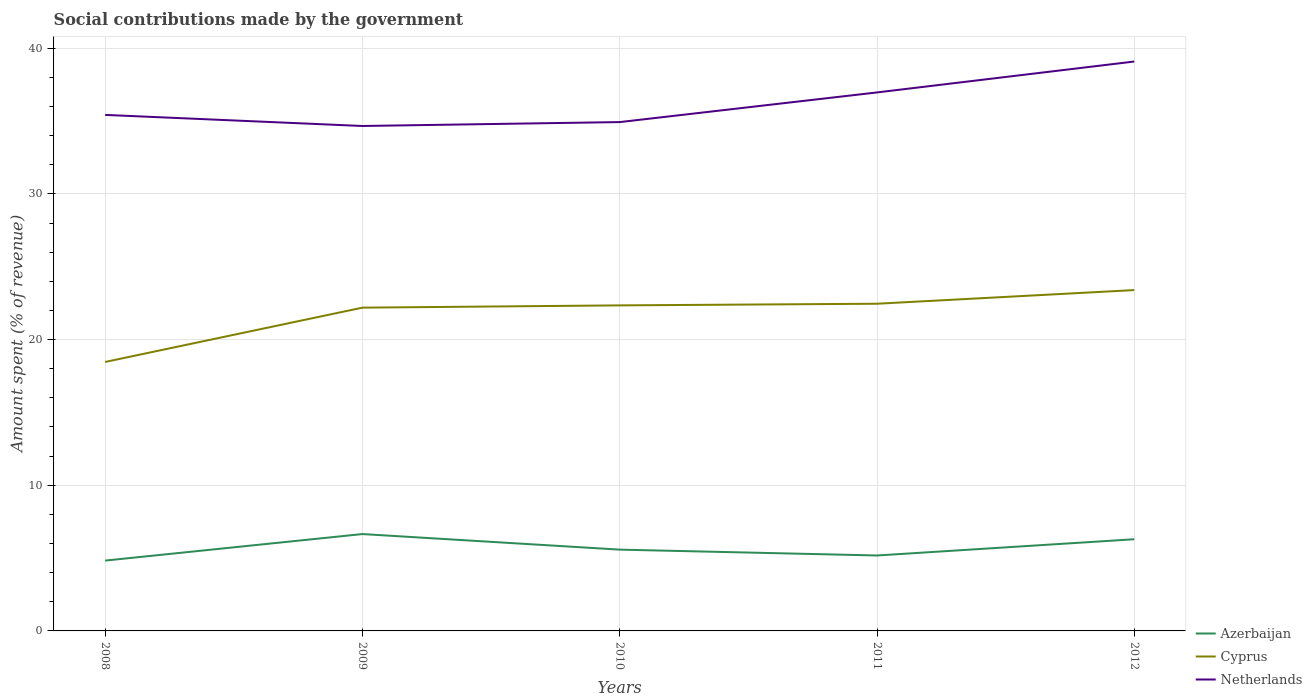How many different coloured lines are there?
Offer a very short reply. 3. Does the line corresponding to Cyprus intersect with the line corresponding to Netherlands?
Provide a succinct answer. No. Is the number of lines equal to the number of legend labels?
Give a very brief answer. Yes. Across all years, what is the maximum amount spent (in %) on social contributions in Azerbaijan?
Offer a terse response. 4.83. What is the total amount spent (in %) on social contributions in Cyprus in the graph?
Make the answer very short. -0.94. What is the difference between the highest and the second highest amount spent (in %) on social contributions in Cyprus?
Give a very brief answer. 4.93. What is the difference between two consecutive major ticks on the Y-axis?
Provide a short and direct response. 10. Are the values on the major ticks of Y-axis written in scientific E-notation?
Provide a short and direct response. No. Does the graph contain grids?
Make the answer very short. Yes. Where does the legend appear in the graph?
Ensure brevity in your answer.  Bottom right. How are the legend labels stacked?
Give a very brief answer. Vertical. What is the title of the graph?
Keep it short and to the point. Social contributions made by the government. What is the label or title of the X-axis?
Your answer should be compact. Years. What is the label or title of the Y-axis?
Provide a short and direct response. Amount spent (% of revenue). What is the Amount spent (% of revenue) of Azerbaijan in 2008?
Give a very brief answer. 4.83. What is the Amount spent (% of revenue) in Cyprus in 2008?
Your answer should be very brief. 18.46. What is the Amount spent (% of revenue) of Netherlands in 2008?
Provide a short and direct response. 35.42. What is the Amount spent (% of revenue) of Azerbaijan in 2009?
Provide a succinct answer. 6.65. What is the Amount spent (% of revenue) in Cyprus in 2009?
Your answer should be compact. 22.19. What is the Amount spent (% of revenue) in Netherlands in 2009?
Your answer should be very brief. 34.66. What is the Amount spent (% of revenue) of Azerbaijan in 2010?
Make the answer very short. 5.58. What is the Amount spent (% of revenue) in Cyprus in 2010?
Keep it short and to the point. 22.35. What is the Amount spent (% of revenue) of Netherlands in 2010?
Give a very brief answer. 34.93. What is the Amount spent (% of revenue) of Azerbaijan in 2011?
Your answer should be very brief. 5.18. What is the Amount spent (% of revenue) in Cyprus in 2011?
Keep it short and to the point. 22.46. What is the Amount spent (% of revenue) in Netherlands in 2011?
Provide a succinct answer. 36.96. What is the Amount spent (% of revenue) of Azerbaijan in 2012?
Your response must be concise. 6.29. What is the Amount spent (% of revenue) in Cyprus in 2012?
Give a very brief answer. 23.4. What is the Amount spent (% of revenue) in Netherlands in 2012?
Offer a terse response. 39.08. Across all years, what is the maximum Amount spent (% of revenue) of Azerbaijan?
Provide a succinct answer. 6.65. Across all years, what is the maximum Amount spent (% of revenue) in Cyprus?
Give a very brief answer. 23.4. Across all years, what is the maximum Amount spent (% of revenue) of Netherlands?
Provide a succinct answer. 39.08. Across all years, what is the minimum Amount spent (% of revenue) of Azerbaijan?
Your response must be concise. 4.83. Across all years, what is the minimum Amount spent (% of revenue) in Cyprus?
Offer a terse response. 18.46. Across all years, what is the minimum Amount spent (% of revenue) of Netherlands?
Ensure brevity in your answer.  34.66. What is the total Amount spent (% of revenue) in Azerbaijan in the graph?
Give a very brief answer. 28.53. What is the total Amount spent (% of revenue) in Cyprus in the graph?
Offer a terse response. 108.85. What is the total Amount spent (% of revenue) in Netherlands in the graph?
Offer a very short reply. 181.05. What is the difference between the Amount spent (% of revenue) of Azerbaijan in 2008 and that in 2009?
Your answer should be very brief. -1.82. What is the difference between the Amount spent (% of revenue) of Cyprus in 2008 and that in 2009?
Your response must be concise. -3.73. What is the difference between the Amount spent (% of revenue) in Netherlands in 2008 and that in 2009?
Your answer should be compact. 0.76. What is the difference between the Amount spent (% of revenue) in Azerbaijan in 2008 and that in 2010?
Your answer should be very brief. -0.75. What is the difference between the Amount spent (% of revenue) in Cyprus in 2008 and that in 2010?
Ensure brevity in your answer.  -3.88. What is the difference between the Amount spent (% of revenue) of Netherlands in 2008 and that in 2010?
Provide a short and direct response. 0.49. What is the difference between the Amount spent (% of revenue) in Azerbaijan in 2008 and that in 2011?
Keep it short and to the point. -0.35. What is the difference between the Amount spent (% of revenue) in Cyprus in 2008 and that in 2011?
Make the answer very short. -4. What is the difference between the Amount spent (% of revenue) in Netherlands in 2008 and that in 2011?
Give a very brief answer. -1.54. What is the difference between the Amount spent (% of revenue) of Azerbaijan in 2008 and that in 2012?
Ensure brevity in your answer.  -1.46. What is the difference between the Amount spent (% of revenue) of Cyprus in 2008 and that in 2012?
Provide a short and direct response. -4.93. What is the difference between the Amount spent (% of revenue) of Netherlands in 2008 and that in 2012?
Ensure brevity in your answer.  -3.66. What is the difference between the Amount spent (% of revenue) of Azerbaijan in 2009 and that in 2010?
Make the answer very short. 1.07. What is the difference between the Amount spent (% of revenue) of Cyprus in 2009 and that in 2010?
Ensure brevity in your answer.  -0.16. What is the difference between the Amount spent (% of revenue) of Netherlands in 2009 and that in 2010?
Keep it short and to the point. -0.27. What is the difference between the Amount spent (% of revenue) of Azerbaijan in 2009 and that in 2011?
Provide a succinct answer. 1.47. What is the difference between the Amount spent (% of revenue) of Cyprus in 2009 and that in 2011?
Your answer should be compact. -0.27. What is the difference between the Amount spent (% of revenue) of Netherlands in 2009 and that in 2011?
Ensure brevity in your answer.  -2.3. What is the difference between the Amount spent (% of revenue) in Azerbaijan in 2009 and that in 2012?
Offer a terse response. 0.36. What is the difference between the Amount spent (% of revenue) in Cyprus in 2009 and that in 2012?
Provide a succinct answer. -1.21. What is the difference between the Amount spent (% of revenue) in Netherlands in 2009 and that in 2012?
Offer a very short reply. -4.42. What is the difference between the Amount spent (% of revenue) of Azerbaijan in 2010 and that in 2011?
Give a very brief answer. 0.4. What is the difference between the Amount spent (% of revenue) of Cyprus in 2010 and that in 2011?
Your answer should be very brief. -0.11. What is the difference between the Amount spent (% of revenue) in Netherlands in 2010 and that in 2011?
Your response must be concise. -2.03. What is the difference between the Amount spent (% of revenue) of Azerbaijan in 2010 and that in 2012?
Your answer should be very brief. -0.71. What is the difference between the Amount spent (% of revenue) of Cyprus in 2010 and that in 2012?
Your answer should be very brief. -1.05. What is the difference between the Amount spent (% of revenue) in Netherlands in 2010 and that in 2012?
Your answer should be very brief. -4.16. What is the difference between the Amount spent (% of revenue) in Azerbaijan in 2011 and that in 2012?
Your response must be concise. -1.11. What is the difference between the Amount spent (% of revenue) of Cyprus in 2011 and that in 2012?
Ensure brevity in your answer.  -0.94. What is the difference between the Amount spent (% of revenue) of Netherlands in 2011 and that in 2012?
Provide a short and direct response. -2.12. What is the difference between the Amount spent (% of revenue) of Azerbaijan in 2008 and the Amount spent (% of revenue) of Cyprus in 2009?
Make the answer very short. -17.36. What is the difference between the Amount spent (% of revenue) of Azerbaijan in 2008 and the Amount spent (% of revenue) of Netherlands in 2009?
Offer a terse response. -29.83. What is the difference between the Amount spent (% of revenue) in Cyprus in 2008 and the Amount spent (% of revenue) in Netherlands in 2009?
Provide a short and direct response. -16.2. What is the difference between the Amount spent (% of revenue) in Azerbaijan in 2008 and the Amount spent (% of revenue) in Cyprus in 2010?
Make the answer very short. -17.52. What is the difference between the Amount spent (% of revenue) of Azerbaijan in 2008 and the Amount spent (% of revenue) of Netherlands in 2010?
Provide a succinct answer. -30.1. What is the difference between the Amount spent (% of revenue) in Cyprus in 2008 and the Amount spent (% of revenue) in Netherlands in 2010?
Provide a short and direct response. -16.46. What is the difference between the Amount spent (% of revenue) in Azerbaijan in 2008 and the Amount spent (% of revenue) in Cyprus in 2011?
Keep it short and to the point. -17.63. What is the difference between the Amount spent (% of revenue) of Azerbaijan in 2008 and the Amount spent (% of revenue) of Netherlands in 2011?
Ensure brevity in your answer.  -32.13. What is the difference between the Amount spent (% of revenue) of Cyprus in 2008 and the Amount spent (% of revenue) of Netherlands in 2011?
Offer a terse response. -18.5. What is the difference between the Amount spent (% of revenue) in Azerbaijan in 2008 and the Amount spent (% of revenue) in Cyprus in 2012?
Keep it short and to the point. -18.57. What is the difference between the Amount spent (% of revenue) in Azerbaijan in 2008 and the Amount spent (% of revenue) in Netherlands in 2012?
Offer a terse response. -34.26. What is the difference between the Amount spent (% of revenue) of Cyprus in 2008 and the Amount spent (% of revenue) of Netherlands in 2012?
Keep it short and to the point. -20.62. What is the difference between the Amount spent (% of revenue) of Azerbaijan in 2009 and the Amount spent (% of revenue) of Cyprus in 2010?
Ensure brevity in your answer.  -15.7. What is the difference between the Amount spent (% of revenue) in Azerbaijan in 2009 and the Amount spent (% of revenue) in Netherlands in 2010?
Offer a very short reply. -28.28. What is the difference between the Amount spent (% of revenue) in Cyprus in 2009 and the Amount spent (% of revenue) in Netherlands in 2010?
Your response must be concise. -12.74. What is the difference between the Amount spent (% of revenue) of Azerbaijan in 2009 and the Amount spent (% of revenue) of Cyprus in 2011?
Make the answer very short. -15.81. What is the difference between the Amount spent (% of revenue) in Azerbaijan in 2009 and the Amount spent (% of revenue) in Netherlands in 2011?
Give a very brief answer. -30.31. What is the difference between the Amount spent (% of revenue) of Cyprus in 2009 and the Amount spent (% of revenue) of Netherlands in 2011?
Offer a terse response. -14.77. What is the difference between the Amount spent (% of revenue) in Azerbaijan in 2009 and the Amount spent (% of revenue) in Cyprus in 2012?
Offer a very short reply. -16.75. What is the difference between the Amount spent (% of revenue) in Azerbaijan in 2009 and the Amount spent (% of revenue) in Netherlands in 2012?
Offer a very short reply. -32.44. What is the difference between the Amount spent (% of revenue) of Cyprus in 2009 and the Amount spent (% of revenue) of Netherlands in 2012?
Offer a terse response. -16.89. What is the difference between the Amount spent (% of revenue) in Azerbaijan in 2010 and the Amount spent (% of revenue) in Cyprus in 2011?
Provide a short and direct response. -16.88. What is the difference between the Amount spent (% of revenue) in Azerbaijan in 2010 and the Amount spent (% of revenue) in Netherlands in 2011?
Keep it short and to the point. -31.38. What is the difference between the Amount spent (% of revenue) in Cyprus in 2010 and the Amount spent (% of revenue) in Netherlands in 2011?
Give a very brief answer. -14.62. What is the difference between the Amount spent (% of revenue) in Azerbaijan in 2010 and the Amount spent (% of revenue) in Cyprus in 2012?
Make the answer very short. -17.82. What is the difference between the Amount spent (% of revenue) of Azerbaijan in 2010 and the Amount spent (% of revenue) of Netherlands in 2012?
Provide a short and direct response. -33.5. What is the difference between the Amount spent (% of revenue) in Cyprus in 2010 and the Amount spent (% of revenue) in Netherlands in 2012?
Provide a succinct answer. -16.74. What is the difference between the Amount spent (% of revenue) of Azerbaijan in 2011 and the Amount spent (% of revenue) of Cyprus in 2012?
Provide a short and direct response. -18.22. What is the difference between the Amount spent (% of revenue) in Azerbaijan in 2011 and the Amount spent (% of revenue) in Netherlands in 2012?
Provide a succinct answer. -33.91. What is the difference between the Amount spent (% of revenue) in Cyprus in 2011 and the Amount spent (% of revenue) in Netherlands in 2012?
Your answer should be compact. -16.63. What is the average Amount spent (% of revenue) of Azerbaijan per year?
Your answer should be compact. 5.71. What is the average Amount spent (% of revenue) of Cyprus per year?
Provide a short and direct response. 21.77. What is the average Amount spent (% of revenue) of Netherlands per year?
Offer a terse response. 36.21. In the year 2008, what is the difference between the Amount spent (% of revenue) of Azerbaijan and Amount spent (% of revenue) of Cyprus?
Provide a succinct answer. -13.64. In the year 2008, what is the difference between the Amount spent (% of revenue) in Azerbaijan and Amount spent (% of revenue) in Netherlands?
Offer a very short reply. -30.59. In the year 2008, what is the difference between the Amount spent (% of revenue) in Cyprus and Amount spent (% of revenue) in Netherlands?
Your response must be concise. -16.96. In the year 2009, what is the difference between the Amount spent (% of revenue) of Azerbaijan and Amount spent (% of revenue) of Cyprus?
Ensure brevity in your answer.  -15.54. In the year 2009, what is the difference between the Amount spent (% of revenue) in Azerbaijan and Amount spent (% of revenue) in Netherlands?
Keep it short and to the point. -28.01. In the year 2009, what is the difference between the Amount spent (% of revenue) of Cyprus and Amount spent (% of revenue) of Netherlands?
Make the answer very short. -12.47. In the year 2010, what is the difference between the Amount spent (% of revenue) of Azerbaijan and Amount spent (% of revenue) of Cyprus?
Offer a terse response. -16.77. In the year 2010, what is the difference between the Amount spent (% of revenue) of Azerbaijan and Amount spent (% of revenue) of Netherlands?
Keep it short and to the point. -29.35. In the year 2010, what is the difference between the Amount spent (% of revenue) in Cyprus and Amount spent (% of revenue) in Netherlands?
Your answer should be compact. -12.58. In the year 2011, what is the difference between the Amount spent (% of revenue) in Azerbaijan and Amount spent (% of revenue) in Cyprus?
Offer a very short reply. -17.28. In the year 2011, what is the difference between the Amount spent (% of revenue) of Azerbaijan and Amount spent (% of revenue) of Netherlands?
Your response must be concise. -31.78. In the year 2011, what is the difference between the Amount spent (% of revenue) in Cyprus and Amount spent (% of revenue) in Netherlands?
Give a very brief answer. -14.5. In the year 2012, what is the difference between the Amount spent (% of revenue) in Azerbaijan and Amount spent (% of revenue) in Cyprus?
Your answer should be very brief. -17.1. In the year 2012, what is the difference between the Amount spent (% of revenue) of Azerbaijan and Amount spent (% of revenue) of Netherlands?
Provide a succinct answer. -32.79. In the year 2012, what is the difference between the Amount spent (% of revenue) in Cyprus and Amount spent (% of revenue) in Netherlands?
Your answer should be very brief. -15.69. What is the ratio of the Amount spent (% of revenue) in Azerbaijan in 2008 to that in 2009?
Offer a very short reply. 0.73. What is the ratio of the Amount spent (% of revenue) of Cyprus in 2008 to that in 2009?
Ensure brevity in your answer.  0.83. What is the ratio of the Amount spent (% of revenue) of Netherlands in 2008 to that in 2009?
Offer a very short reply. 1.02. What is the ratio of the Amount spent (% of revenue) of Azerbaijan in 2008 to that in 2010?
Your answer should be compact. 0.87. What is the ratio of the Amount spent (% of revenue) in Cyprus in 2008 to that in 2010?
Keep it short and to the point. 0.83. What is the ratio of the Amount spent (% of revenue) in Netherlands in 2008 to that in 2010?
Offer a very short reply. 1.01. What is the ratio of the Amount spent (% of revenue) of Azerbaijan in 2008 to that in 2011?
Offer a terse response. 0.93. What is the ratio of the Amount spent (% of revenue) of Cyprus in 2008 to that in 2011?
Your response must be concise. 0.82. What is the ratio of the Amount spent (% of revenue) in Azerbaijan in 2008 to that in 2012?
Your answer should be very brief. 0.77. What is the ratio of the Amount spent (% of revenue) of Cyprus in 2008 to that in 2012?
Provide a short and direct response. 0.79. What is the ratio of the Amount spent (% of revenue) in Netherlands in 2008 to that in 2012?
Your answer should be compact. 0.91. What is the ratio of the Amount spent (% of revenue) of Azerbaijan in 2009 to that in 2010?
Make the answer very short. 1.19. What is the ratio of the Amount spent (% of revenue) in Netherlands in 2009 to that in 2010?
Give a very brief answer. 0.99. What is the ratio of the Amount spent (% of revenue) in Azerbaijan in 2009 to that in 2011?
Provide a succinct answer. 1.28. What is the ratio of the Amount spent (% of revenue) of Cyprus in 2009 to that in 2011?
Your answer should be compact. 0.99. What is the ratio of the Amount spent (% of revenue) in Netherlands in 2009 to that in 2011?
Give a very brief answer. 0.94. What is the ratio of the Amount spent (% of revenue) of Azerbaijan in 2009 to that in 2012?
Provide a succinct answer. 1.06. What is the ratio of the Amount spent (% of revenue) of Cyprus in 2009 to that in 2012?
Keep it short and to the point. 0.95. What is the ratio of the Amount spent (% of revenue) in Netherlands in 2009 to that in 2012?
Your response must be concise. 0.89. What is the ratio of the Amount spent (% of revenue) in Azerbaijan in 2010 to that in 2011?
Offer a terse response. 1.08. What is the ratio of the Amount spent (% of revenue) of Netherlands in 2010 to that in 2011?
Provide a succinct answer. 0.94. What is the ratio of the Amount spent (% of revenue) of Azerbaijan in 2010 to that in 2012?
Ensure brevity in your answer.  0.89. What is the ratio of the Amount spent (% of revenue) in Cyprus in 2010 to that in 2012?
Ensure brevity in your answer.  0.96. What is the ratio of the Amount spent (% of revenue) of Netherlands in 2010 to that in 2012?
Ensure brevity in your answer.  0.89. What is the ratio of the Amount spent (% of revenue) in Azerbaijan in 2011 to that in 2012?
Provide a short and direct response. 0.82. What is the ratio of the Amount spent (% of revenue) in Cyprus in 2011 to that in 2012?
Give a very brief answer. 0.96. What is the ratio of the Amount spent (% of revenue) of Netherlands in 2011 to that in 2012?
Provide a short and direct response. 0.95. What is the difference between the highest and the second highest Amount spent (% of revenue) in Azerbaijan?
Your answer should be compact. 0.36. What is the difference between the highest and the second highest Amount spent (% of revenue) of Cyprus?
Provide a short and direct response. 0.94. What is the difference between the highest and the second highest Amount spent (% of revenue) in Netherlands?
Offer a very short reply. 2.12. What is the difference between the highest and the lowest Amount spent (% of revenue) in Azerbaijan?
Make the answer very short. 1.82. What is the difference between the highest and the lowest Amount spent (% of revenue) of Cyprus?
Offer a very short reply. 4.93. What is the difference between the highest and the lowest Amount spent (% of revenue) in Netherlands?
Provide a succinct answer. 4.42. 